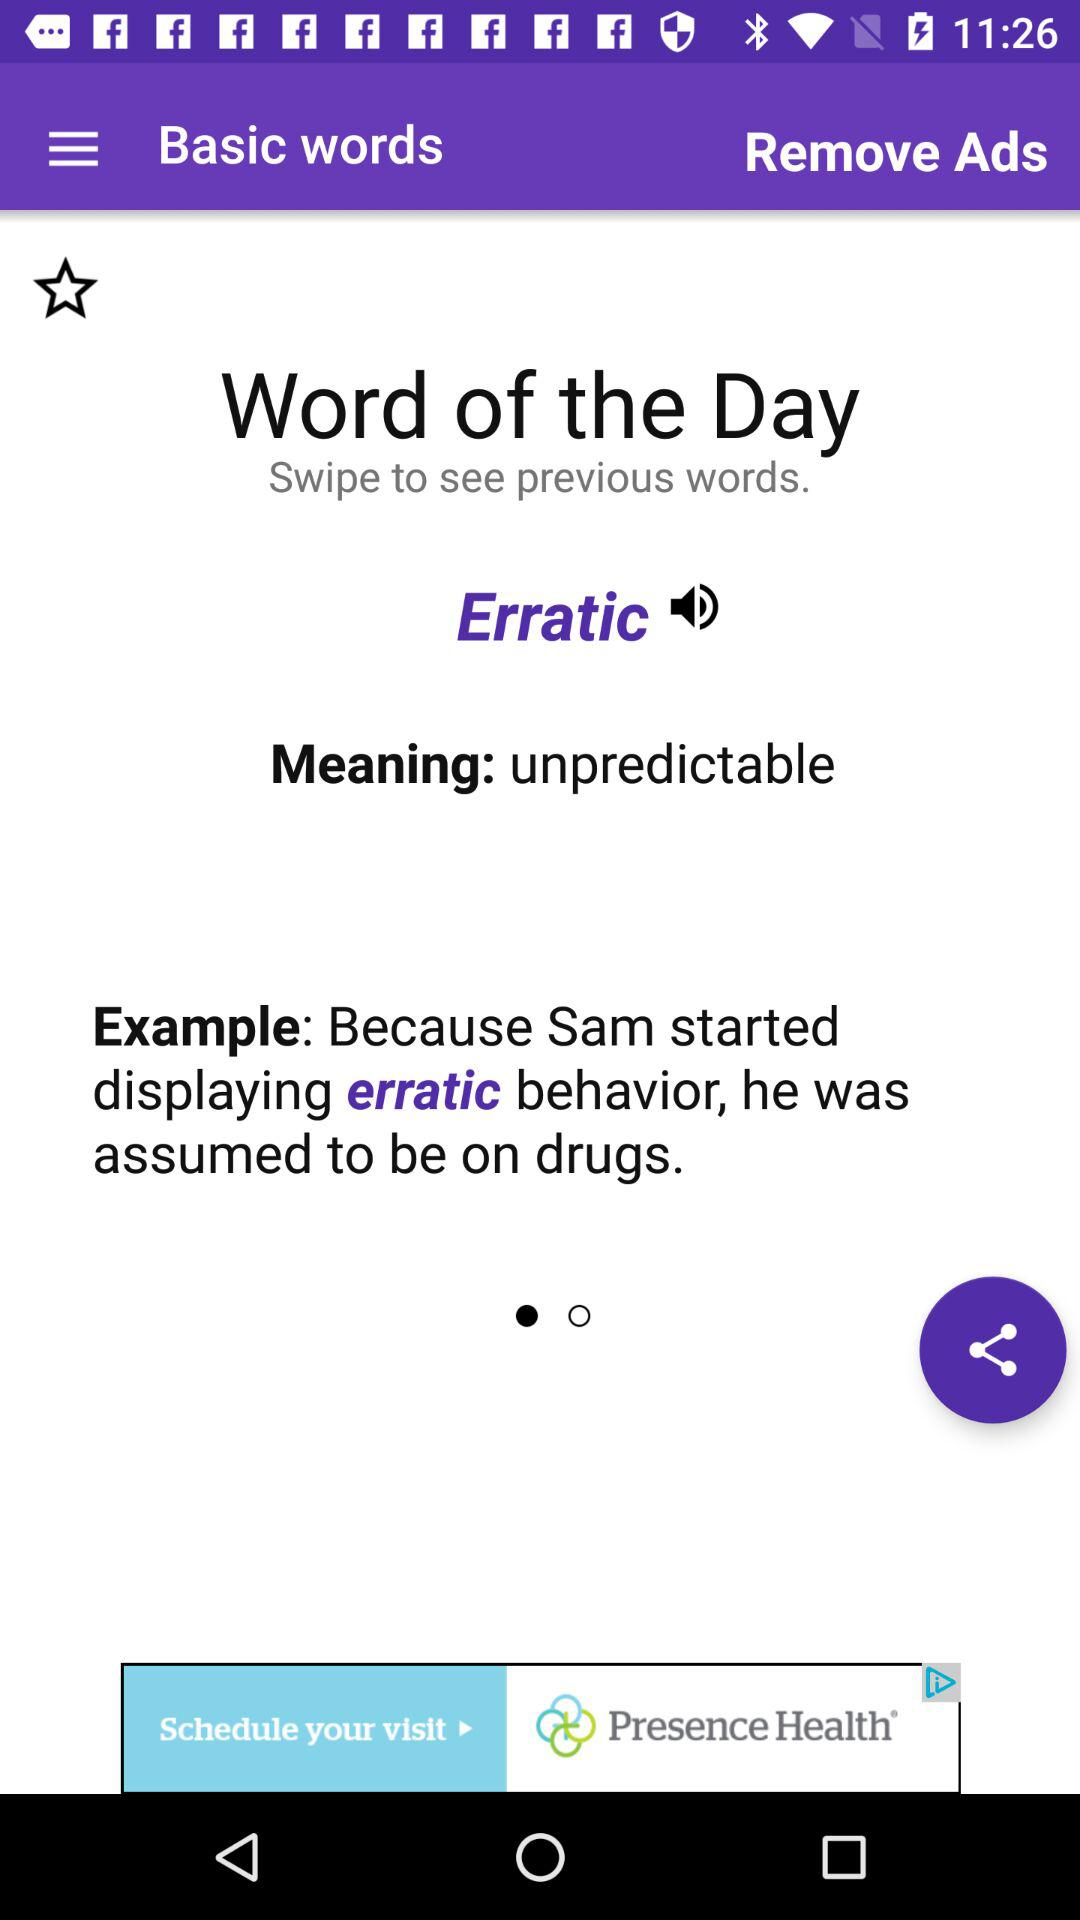What does "Erratic" mean?
Answer the question using a single word or phrase. "Erratic" means unpredictable. 